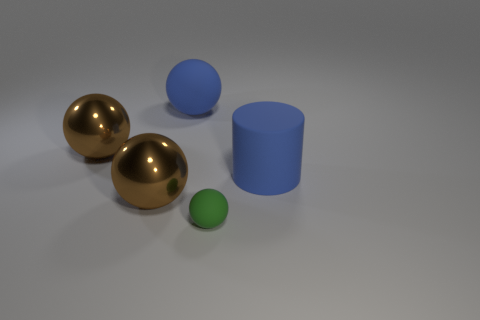Are there any objects overlapping or touching? No, all objects are separate and spaced apart from each other, with no overlap or physical contact visible in the image. 